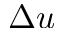<formula> <loc_0><loc_0><loc_500><loc_500>\Delta u</formula> 